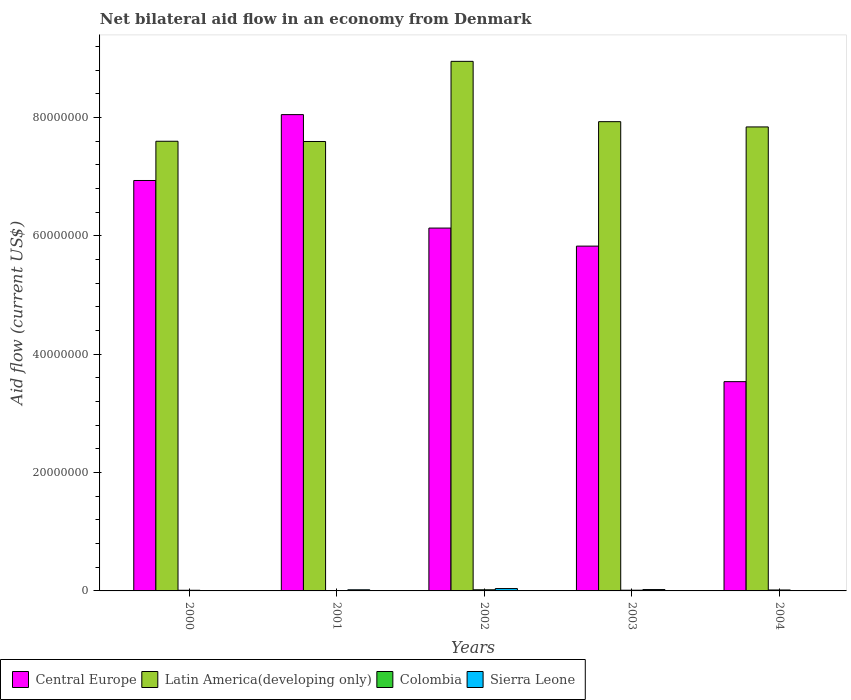How many different coloured bars are there?
Provide a succinct answer. 4. How many groups of bars are there?
Provide a succinct answer. 5. Are the number of bars on each tick of the X-axis equal?
Your answer should be compact. No. How many bars are there on the 5th tick from the left?
Provide a succinct answer. 3. What is the label of the 1st group of bars from the left?
Keep it short and to the point. 2000. In how many cases, is the number of bars for a given year not equal to the number of legend labels?
Offer a terse response. 1. What is the net bilateral aid flow in Central Europe in 2002?
Offer a terse response. 6.13e+07. Across all years, what is the maximum net bilateral aid flow in Central Europe?
Your answer should be compact. 8.05e+07. Across all years, what is the minimum net bilateral aid flow in Latin America(developing only)?
Your response must be concise. 7.59e+07. In which year was the net bilateral aid flow in Central Europe maximum?
Your answer should be very brief. 2001. What is the total net bilateral aid flow in Latin America(developing only) in the graph?
Ensure brevity in your answer.  3.99e+08. What is the difference between the net bilateral aid flow in Central Europe in 2001 and that in 2004?
Your answer should be very brief. 4.51e+07. What is the difference between the net bilateral aid flow in Central Europe in 2000 and the net bilateral aid flow in Sierra Leone in 2001?
Make the answer very short. 6.92e+07. What is the average net bilateral aid flow in Latin America(developing only) per year?
Your answer should be compact. 7.98e+07. In the year 2001, what is the difference between the net bilateral aid flow in Colombia and net bilateral aid flow in Central Europe?
Make the answer very short. -8.04e+07. What is the ratio of the net bilateral aid flow in Central Europe in 2000 to that in 2001?
Your answer should be very brief. 0.86. Is the net bilateral aid flow in Latin America(developing only) in 2000 less than that in 2004?
Offer a very short reply. Yes. What is the difference between the highest and the second highest net bilateral aid flow in Colombia?
Offer a very short reply. 3.00e+04. Is the sum of the net bilateral aid flow in Central Europe in 2000 and 2003 greater than the maximum net bilateral aid flow in Sierra Leone across all years?
Give a very brief answer. Yes. Is it the case that in every year, the sum of the net bilateral aid flow in Latin America(developing only) and net bilateral aid flow in Sierra Leone is greater than the sum of net bilateral aid flow in Central Europe and net bilateral aid flow in Colombia?
Make the answer very short. No. How many bars are there?
Offer a very short reply. 19. Are all the bars in the graph horizontal?
Keep it short and to the point. No. How many years are there in the graph?
Ensure brevity in your answer.  5. Are the values on the major ticks of Y-axis written in scientific E-notation?
Provide a succinct answer. No. Does the graph contain grids?
Provide a succinct answer. No. How are the legend labels stacked?
Offer a very short reply. Horizontal. What is the title of the graph?
Make the answer very short. Net bilateral aid flow in an economy from Denmark. What is the label or title of the X-axis?
Offer a terse response. Years. What is the label or title of the Y-axis?
Your answer should be very brief. Aid flow (current US$). What is the Aid flow (current US$) in Central Europe in 2000?
Make the answer very short. 6.94e+07. What is the Aid flow (current US$) in Latin America(developing only) in 2000?
Make the answer very short. 7.60e+07. What is the Aid flow (current US$) of Sierra Leone in 2000?
Provide a short and direct response. 3.00e+04. What is the Aid flow (current US$) of Central Europe in 2001?
Your answer should be compact. 8.05e+07. What is the Aid flow (current US$) in Latin America(developing only) in 2001?
Provide a succinct answer. 7.59e+07. What is the Aid flow (current US$) of Colombia in 2001?
Ensure brevity in your answer.  4.00e+04. What is the Aid flow (current US$) of Sierra Leone in 2001?
Offer a very short reply. 1.90e+05. What is the Aid flow (current US$) of Central Europe in 2002?
Your answer should be very brief. 6.13e+07. What is the Aid flow (current US$) of Latin America(developing only) in 2002?
Your response must be concise. 8.95e+07. What is the Aid flow (current US$) in Sierra Leone in 2002?
Offer a very short reply. 4.00e+05. What is the Aid flow (current US$) in Central Europe in 2003?
Your answer should be compact. 5.83e+07. What is the Aid flow (current US$) of Latin America(developing only) in 2003?
Offer a very short reply. 7.93e+07. What is the Aid flow (current US$) of Colombia in 2003?
Your answer should be very brief. 1.20e+05. What is the Aid flow (current US$) of Central Europe in 2004?
Your answer should be compact. 3.54e+07. What is the Aid flow (current US$) of Latin America(developing only) in 2004?
Offer a terse response. 7.84e+07. Across all years, what is the maximum Aid flow (current US$) of Central Europe?
Provide a short and direct response. 8.05e+07. Across all years, what is the maximum Aid flow (current US$) in Latin America(developing only)?
Give a very brief answer. 8.95e+07. Across all years, what is the maximum Aid flow (current US$) in Colombia?
Ensure brevity in your answer.  1.90e+05. Across all years, what is the maximum Aid flow (current US$) of Sierra Leone?
Your answer should be very brief. 4.00e+05. Across all years, what is the minimum Aid flow (current US$) in Central Europe?
Ensure brevity in your answer.  3.54e+07. Across all years, what is the minimum Aid flow (current US$) of Latin America(developing only)?
Give a very brief answer. 7.59e+07. Across all years, what is the minimum Aid flow (current US$) in Colombia?
Your answer should be compact. 4.00e+04. Across all years, what is the minimum Aid flow (current US$) of Sierra Leone?
Provide a short and direct response. 0. What is the total Aid flow (current US$) in Central Europe in the graph?
Provide a short and direct response. 3.05e+08. What is the total Aid flow (current US$) in Latin America(developing only) in the graph?
Give a very brief answer. 3.99e+08. What is the total Aid flow (current US$) of Colombia in the graph?
Provide a short and direct response. 6.20e+05. What is the total Aid flow (current US$) in Sierra Leone in the graph?
Keep it short and to the point. 8.50e+05. What is the difference between the Aid flow (current US$) in Central Europe in 2000 and that in 2001?
Offer a very short reply. -1.11e+07. What is the difference between the Aid flow (current US$) in Latin America(developing only) in 2000 and that in 2001?
Make the answer very short. 4.00e+04. What is the difference between the Aid flow (current US$) in Colombia in 2000 and that in 2001?
Your answer should be very brief. 7.00e+04. What is the difference between the Aid flow (current US$) of Sierra Leone in 2000 and that in 2001?
Give a very brief answer. -1.60e+05. What is the difference between the Aid flow (current US$) in Central Europe in 2000 and that in 2002?
Your answer should be compact. 8.04e+06. What is the difference between the Aid flow (current US$) in Latin America(developing only) in 2000 and that in 2002?
Your answer should be compact. -1.35e+07. What is the difference between the Aid flow (current US$) of Colombia in 2000 and that in 2002?
Give a very brief answer. -8.00e+04. What is the difference between the Aid flow (current US$) of Sierra Leone in 2000 and that in 2002?
Ensure brevity in your answer.  -3.70e+05. What is the difference between the Aid flow (current US$) in Central Europe in 2000 and that in 2003?
Make the answer very short. 1.11e+07. What is the difference between the Aid flow (current US$) in Latin America(developing only) in 2000 and that in 2003?
Offer a terse response. -3.31e+06. What is the difference between the Aid flow (current US$) of Colombia in 2000 and that in 2003?
Give a very brief answer. -10000. What is the difference between the Aid flow (current US$) in Sierra Leone in 2000 and that in 2003?
Give a very brief answer. -2.00e+05. What is the difference between the Aid flow (current US$) in Central Europe in 2000 and that in 2004?
Your answer should be very brief. 3.40e+07. What is the difference between the Aid flow (current US$) of Latin America(developing only) in 2000 and that in 2004?
Your response must be concise. -2.42e+06. What is the difference between the Aid flow (current US$) of Central Europe in 2001 and that in 2002?
Offer a very short reply. 1.92e+07. What is the difference between the Aid flow (current US$) in Latin America(developing only) in 2001 and that in 2002?
Your response must be concise. -1.35e+07. What is the difference between the Aid flow (current US$) in Colombia in 2001 and that in 2002?
Make the answer very short. -1.50e+05. What is the difference between the Aid flow (current US$) in Sierra Leone in 2001 and that in 2002?
Provide a succinct answer. -2.10e+05. What is the difference between the Aid flow (current US$) of Central Europe in 2001 and that in 2003?
Provide a short and direct response. 2.22e+07. What is the difference between the Aid flow (current US$) in Latin America(developing only) in 2001 and that in 2003?
Your answer should be compact. -3.35e+06. What is the difference between the Aid flow (current US$) in Sierra Leone in 2001 and that in 2003?
Give a very brief answer. -4.00e+04. What is the difference between the Aid flow (current US$) of Central Europe in 2001 and that in 2004?
Your answer should be very brief. 4.51e+07. What is the difference between the Aid flow (current US$) in Latin America(developing only) in 2001 and that in 2004?
Offer a terse response. -2.46e+06. What is the difference between the Aid flow (current US$) in Colombia in 2001 and that in 2004?
Give a very brief answer. -1.20e+05. What is the difference between the Aid flow (current US$) in Central Europe in 2002 and that in 2003?
Keep it short and to the point. 3.05e+06. What is the difference between the Aid flow (current US$) in Latin America(developing only) in 2002 and that in 2003?
Your answer should be very brief. 1.02e+07. What is the difference between the Aid flow (current US$) of Colombia in 2002 and that in 2003?
Your response must be concise. 7.00e+04. What is the difference between the Aid flow (current US$) in Sierra Leone in 2002 and that in 2003?
Ensure brevity in your answer.  1.70e+05. What is the difference between the Aid flow (current US$) in Central Europe in 2002 and that in 2004?
Make the answer very short. 2.60e+07. What is the difference between the Aid flow (current US$) of Latin America(developing only) in 2002 and that in 2004?
Make the answer very short. 1.11e+07. What is the difference between the Aid flow (current US$) of Colombia in 2002 and that in 2004?
Ensure brevity in your answer.  3.00e+04. What is the difference between the Aid flow (current US$) of Central Europe in 2003 and that in 2004?
Offer a very short reply. 2.29e+07. What is the difference between the Aid flow (current US$) in Latin America(developing only) in 2003 and that in 2004?
Keep it short and to the point. 8.90e+05. What is the difference between the Aid flow (current US$) of Central Europe in 2000 and the Aid flow (current US$) of Latin America(developing only) in 2001?
Offer a terse response. -6.59e+06. What is the difference between the Aid flow (current US$) of Central Europe in 2000 and the Aid flow (current US$) of Colombia in 2001?
Make the answer very short. 6.93e+07. What is the difference between the Aid flow (current US$) in Central Europe in 2000 and the Aid flow (current US$) in Sierra Leone in 2001?
Offer a terse response. 6.92e+07. What is the difference between the Aid flow (current US$) in Latin America(developing only) in 2000 and the Aid flow (current US$) in Colombia in 2001?
Ensure brevity in your answer.  7.59e+07. What is the difference between the Aid flow (current US$) in Latin America(developing only) in 2000 and the Aid flow (current US$) in Sierra Leone in 2001?
Offer a terse response. 7.58e+07. What is the difference between the Aid flow (current US$) of Colombia in 2000 and the Aid flow (current US$) of Sierra Leone in 2001?
Provide a succinct answer. -8.00e+04. What is the difference between the Aid flow (current US$) in Central Europe in 2000 and the Aid flow (current US$) in Latin America(developing only) in 2002?
Your answer should be very brief. -2.01e+07. What is the difference between the Aid flow (current US$) of Central Europe in 2000 and the Aid flow (current US$) of Colombia in 2002?
Your response must be concise. 6.92e+07. What is the difference between the Aid flow (current US$) of Central Europe in 2000 and the Aid flow (current US$) of Sierra Leone in 2002?
Offer a terse response. 6.90e+07. What is the difference between the Aid flow (current US$) in Latin America(developing only) in 2000 and the Aid flow (current US$) in Colombia in 2002?
Your response must be concise. 7.58e+07. What is the difference between the Aid flow (current US$) in Latin America(developing only) in 2000 and the Aid flow (current US$) in Sierra Leone in 2002?
Give a very brief answer. 7.56e+07. What is the difference between the Aid flow (current US$) in Colombia in 2000 and the Aid flow (current US$) in Sierra Leone in 2002?
Keep it short and to the point. -2.90e+05. What is the difference between the Aid flow (current US$) in Central Europe in 2000 and the Aid flow (current US$) in Latin America(developing only) in 2003?
Provide a succinct answer. -9.94e+06. What is the difference between the Aid flow (current US$) in Central Europe in 2000 and the Aid flow (current US$) in Colombia in 2003?
Provide a succinct answer. 6.92e+07. What is the difference between the Aid flow (current US$) of Central Europe in 2000 and the Aid flow (current US$) of Sierra Leone in 2003?
Your answer should be very brief. 6.91e+07. What is the difference between the Aid flow (current US$) of Latin America(developing only) in 2000 and the Aid flow (current US$) of Colombia in 2003?
Offer a terse response. 7.59e+07. What is the difference between the Aid flow (current US$) of Latin America(developing only) in 2000 and the Aid flow (current US$) of Sierra Leone in 2003?
Make the answer very short. 7.58e+07. What is the difference between the Aid flow (current US$) in Colombia in 2000 and the Aid flow (current US$) in Sierra Leone in 2003?
Ensure brevity in your answer.  -1.20e+05. What is the difference between the Aid flow (current US$) in Central Europe in 2000 and the Aid flow (current US$) in Latin America(developing only) in 2004?
Your response must be concise. -9.05e+06. What is the difference between the Aid flow (current US$) in Central Europe in 2000 and the Aid flow (current US$) in Colombia in 2004?
Provide a succinct answer. 6.92e+07. What is the difference between the Aid flow (current US$) in Latin America(developing only) in 2000 and the Aid flow (current US$) in Colombia in 2004?
Give a very brief answer. 7.58e+07. What is the difference between the Aid flow (current US$) in Central Europe in 2001 and the Aid flow (current US$) in Latin America(developing only) in 2002?
Provide a short and direct response. -9.00e+06. What is the difference between the Aid flow (current US$) of Central Europe in 2001 and the Aid flow (current US$) of Colombia in 2002?
Give a very brief answer. 8.03e+07. What is the difference between the Aid flow (current US$) of Central Europe in 2001 and the Aid flow (current US$) of Sierra Leone in 2002?
Your answer should be very brief. 8.01e+07. What is the difference between the Aid flow (current US$) in Latin America(developing only) in 2001 and the Aid flow (current US$) in Colombia in 2002?
Give a very brief answer. 7.58e+07. What is the difference between the Aid flow (current US$) in Latin America(developing only) in 2001 and the Aid flow (current US$) in Sierra Leone in 2002?
Provide a short and direct response. 7.55e+07. What is the difference between the Aid flow (current US$) in Colombia in 2001 and the Aid flow (current US$) in Sierra Leone in 2002?
Your response must be concise. -3.60e+05. What is the difference between the Aid flow (current US$) of Central Europe in 2001 and the Aid flow (current US$) of Latin America(developing only) in 2003?
Keep it short and to the point. 1.19e+06. What is the difference between the Aid flow (current US$) of Central Europe in 2001 and the Aid flow (current US$) of Colombia in 2003?
Your answer should be very brief. 8.04e+07. What is the difference between the Aid flow (current US$) of Central Europe in 2001 and the Aid flow (current US$) of Sierra Leone in 2003?
Provide a succinct answer. 8.02e+07. What is the difference between the Aid flow (current US$) in Latin America(developing only) in 2001 and the Aid flow (current US$) in Colombia in 2003?
Provide a short and direct response. 7.58e+07. What is the difference between the Aid flow (current US$) in Latin America(developing only) in 2001 and the Aid flow (current US$) in Sierra Leone in 2003?
Offer a very short reply. 7.57e+07. What is the difference between the Aid flow (current US$) of Colombia in 2001 and the Aid flow (current US$) of Sierra Leone in 2003?
Give a very brief answer. -1.90e+05. What is the difference between the Aid flow (current US$) of Central Europe in 2001 and the Aid flow (current US$) of Latin America(developing only) in 2004?
Your answer should be compact. 2.08e+06. What is the difference between the Aid flow (current US$) of Central Europe in 2001 and the Aid flow (current US$) of Colombia in 2004?
Keep it short and to the point. 8.03e+07. What is the difference between the Aid flow (current US$) of Latin America(developing only) in 2001 and the Aid flow (current US$) of Colombia in 2004?
Make the answer very short. 7.58e+07. What is the difference between the Aid flow (current US$) in Central Europe in 2002 and the Aid flow (current US$) in Latin America(developing only) in 2003?
Your response must be concise. -1.80e+07. What is the difference between the Aid flow (current US$) in Central Europe in 2002 and the Aid flow (current US$) in Colombia in 2003?
Make the answer very short. 6.12e+07. What is the difference between the Aid flow (current US$) in Central Europe in 2002 and the Aid flow (current US$) in Sierra Leone in 2003?
Your answer should be compact. 6.11e+07. What is the difference between the Aid flow (current US$) of Latin America(developing only) in 2002 and the Aid flow (current US$) of Colombia in 2003?
Offer a terse response. 8.94e+07. What is the difference between the Aid flow (current US$) of Latin America(developing only) in 2002 and the Aid flow (current US$) of Sierra Leone in 2003?
Your answer should be compact. 8.92e+07. What is the difference between the Aid flow (current US$) of Colombia in 2002 and the Aid flow (current US$) of Sierra Leone in 2003?
Offer a very short reply. -4.00e+04. What is the difference between the Aid flow (current US$) of Central Europe in 2002 and the Aid flow (current US$) of Latin America(developing only) in 2004?
Ensure brevity in your answer.  -1.71e+07. What is the difference between the Aid flow (current US$) of Central Europe in 2002 and the Aid flow (current US$) of Colombia in 2004?
Provide a short and direct response. 6.12e+07. What is the difference between the Aid flow (current US$) in Latin America(developing only) in 2002 and the Aid flow (current US$) in Colombia in 2004?
Give a very brief answer. 8.93e+07. What is the difference between the Aid flow (current US$) of Central Europe in 2003 and the Aid flow (current US$) of Latin America(developing only) in 2004?
Provide a short and direct response. -2.01e+07. What is the difference between the Aid flow (current US$) of Central Europe in 2003 and the Aid flow (current US$) of Colombia in 2004?
Provide a short and direct response. 5.81e+07. What is the difference between the Aid flow (current US$) in Latin America(developing only) in 2003 and the Aid flow (current US$) in Colombia in 2004?
Give a very brief answer. 7.91e+07. What is the average Aid flow (current US$) of Central Europe per year?
Give a very brief answer. 6.10e+07. What is the average Aid flow (current US$) of Latin America(developing only) per year?
Your response must be concise. 7.98e+07. What is the average Aid flow (current US$) of Colombia per year?
Provide a succinct answer. 1.24e+05. In the year 2000, what is the difference between the Aid flow (current US$) of Central Europe and Aid flow (current US$) of Latin America(developing only)?
Offer a very short reply. -6.63e+06. In the year 2000, what is the difference between the Aid flow (current US$) in Central Europe and Aid flow (current US$) in Colombia?
Provide a short and direct response. 6.92e+07. In the year 2000, what is the difference between the Aid flow (current US$) of Central Europe and Aid flow (current US$) of Sierra Leone?
Your answer should be very brief. 6.93e+07. In the year 2000, what is the difference between the Aid flow (current US$) of Latin America(developing only) and Aid flow (current US$) of Colombia?
Ensure brevity in your answer.  7.59e+07. In the year 2000, what is the difference between the Aid flow (current US$) in Latin America(developing only) and Aid flow (current US$) in Sierra Leone?
Provide a succinct answer. 7.60e+07. In the year 2000, what is the difference between the Aid flow (current US$) in Colombia and Aid flow (current US$) in Sierra Leone?
Provide a succinct answer. 8.00e+04. In the year 2001, what is the difference between the Aid flow (current US$) of Central Europe and Aid flow (current US$) of Latin America(developing only)?
Offer a very short reply. 4.54e+06. In the year 2001, what is the difference between the Aid flow (current US$) in Central Europe and Aid flow (current US$) in Colombia?
Keep it short and to the point. 8.04e+07. In the year 2001, what is the difference between the Aid flow (current US$) in Central Europe and Aid flow (current US$) in Sierra Leone?
Ensure brevity in your answer.  8.03e+07. In the year 2001, what is the difference between the Aid flow (current US$) of Latin America(developing only) and Aid flow (current US$) of Colombia?
Provide a short and direct response. 7.59e+07. In the year 2001, what is the difference between the Aid flow (current US$) in Latin America(developing only) and Aid flow (current US$) in Sierra Leone?
Give a very brief answer. 7.58e+07. In the year 2002, what is the difference between the Aid flow (current US$) in Central Europe and Aid flow (current US$) in Latin America(developing only)?
Provide a succinct answer. -2.82e+07. In the year 2002, what is the difference between the Aid flow (current US$) in Central Europe and Aid flow (current US$) in Colombia?
Your answer should be very brief. 6.11e+07. In the year 2002, what is the difference between the Aid flow (current US$) in Central Europe and Aid flow (current US$) in Sierra Leone?
Keep it short and to the point. 6.09e+07. In the year 2002, what is the difference between the Aid flow (current US$) in Latin America(developing only) and Aid flow (current US$) in Colombia?
Make the answer very short. 8.93e+07. In the year 2002, what is the difference between the Aid flow (current US$) in Latin America(developing only) and Aid flow (current US$) in Sierra Leone?
Your answer should be compact. 8.91e+07. In the year 2002, what is the difference between the Aid flow (current US$) of Colombia and Aid flow (current US$) of Sierra Leone?
Offer a terse response. -2.10e+05. In the year 2003, what is the difference between the Aid flow (current US$) of Central Europe and Aid flow (current US$) of Latin America(developing only)?
Offer a very short reply. -2.10e+07. In the year 2003, what is the difference between the Aid flow (current US$) in Central Europe and Aid flow (current US$) in Colombia?
Give a very brief answer. 5.81e+07. In the year 2003, what is the difference between the Aid flow (current US$) in Central Europe and Aid flow (current US$) in Sierra Leone?
Offer a very short reply. 5.80e+07. In the year 2003, what is the difference between the Aid flow (current US$) of Latin America(developing only) and Aid flow (current US$) of Colombia?
Provide a short and direct response. 7.92e+07. In the year 2003, what is the difference between the Aid flow (current US$) in Latin America(developing only) and Aid flow (current US$) in Sierra Leone?
Keep it short and to the point. 7.91e+07. In the year 2003, what is the difference between the Aid flow (current US$) of Colombia and Aid flow (current US$) of Sierra Leone?
Offer a terse response. -1.10e+05. In the year 2004, what is the difference between the Aid flow (current US$) of Central Europe and Aid flow (current US$) of Latin America(developing only)?
Offer a very short reply. -4.30e+07. In the year 2004, what is the difference between the Aid flow (current US$) of Central Europe and Aid flow (current US$) of Colombia?
Offer a very short reply. 3.52e+07. In the year 2004, what is the difference between the Aid flow (current US$) in Latin America(developing only) and Aid flow (current US$) in Colombia?
Ensure brevity in your answer.  7.82e+07. What is the ratio of the Aid flow (current US$) of Central Europe in 2000 to that in 2001?
Make the answer very short. 0.86. What is the ratio of the Aid flow (current US$) of Colombia in 2000 to that in 2001?
Provide a short and direct response. 2.75. What is the ratio of the Aid flow (current US$) in Sierra Leone in 2000 to that in 2001?
Offer a very short reply. 0.16. What is the ratio of the Aid flow (current US$) in Central Europe in 2000 to that in 2002?
Give a very brief answer. 1.13. What is the ratio of the Aid flow (current US$) of Latin America(developing only) in 2000 to that in 2002?
Provide a succinct answer. 0.85. What is the ratio of the Aid flow (current US$) of Colombia in 2000 to that in 2002?
Keep it short and to the point. 0.58. What is the ratio of the Aid flow (current US$) of Sierra Leone in 2000 to that in 2002?
Ensure brevity in your answer.  0.07. What is the ratio of the Aid flow (current US$) of Central Europe in 2000 to that in 2003?
Provide a succinct answer. 1.19. What is the ratio of the Aid flow (current US$) of Colombia in 2000 to that in 2003?
Your answer should be compact. 0.92. What is the ratio of the Aid flow (current US$) in Sierra Leone in 2000 to that in 2003?
Your answer should be very brief. 0.13. What is the ratio of the Aid flow (current US$) in Central Europe in 2000 to that in 2004?
Offer a terse response. 1.96. What is the ratio of the Aid flow (current US$) in Latin America(developing only) in 2000 to that in 2004?
Give a very brief answer. 0.97. What is the ratio of the Aid flow (current US$) of Colombia in 2000 to that in 2004?
Give a very brief answer. 0.69. What is the ratio of the Aid flow (current US$) of Central Europe in 2001 to that in 2002?
Your response must be concise. 1.31. What is the ratio of the Aid flow (current US$) of Latin America(developing only) in 2001 to that in 2002?
Keep it short and to the point. 0.85. What is the ratio of the Aid flow (current US$) in Colombia in 2001 to that in 2002?
Offer a terse response. 0.21. What is the ratio of the Aid flow (current US$) in Sierra Leone in 2001 to that in 2002?
Offer a terse response. 0.47. What is the ratio of the Aid flow (current US$) of Central Europe in 2001 to that in 2003?
Provide a short and direct response. 1.38. What is the ratio of the Aid flow (current US$) of Latin America(developing only) in 2001 to that in 2003?
Offer a very short reply. 0.96. What is the ratio of the Aid flow (current US$) in Colombia in 2001 to that in 2003?
Give a very brief answer. 0.33. What is the ratio of the Aid flow (current US$) of Sierra Leone in 2001 to that in 2003?
Provide a short and direct response. 0.83. What is the ratio of the Aid flow (current US$) in Central Europe in 2001 to that in 2004?
Provide a short and direct response. 2.28. What is the ratio of the Aid flow (current US$) of Latin America(developing only) in 2001 to that in 2004?
Offer a very short reply. 0.97. What is the ratio of the Aid flow (current US$) of Central Europe in 2002 to that in 2003?
Keep it short and to the point. 1.05. What is the ratio of the Aid flow (current US$) of Latin America(developing only) in 2002 to that in 2003?
Make the answer very short. 1.13. What is the ratio of the Aid flow (current US$) in Colombia in 2002 to that in 2003?
Provide a succinct answer. 1.58. What is the ratio of the Aid flow (current US$) of Sierra Leone in 2002 to that in 2003?
Provide a short and direct response. 1.74. What is the ratio of the Aid flow (current US$) in Central Europe in 2002 to that in 2004?
Keep it short and to the point. 1.73. What is the ratio of the Aid flow (current US$) in Latin America(developing only) in 2002 to that in 2004?
Offer a terse response. 1.14. What is the ratio of the Aid flow (current US$) in Colombia in 2002 to that in 2004?
Your answer should be very brief. 1.19. What is the ratio of the Aid flow (current US$) in Central Europe in 2003 to that in 2004?
Provide a succinct answer. 1.65. What is the ratio of the Aid flow (current US$) in Latin America(developing only) in 2003 to that in 2004?
Offer a terse response. 1.01. What is the difference between the highest and the second highest Aid flow (current US$) in Central Europe?
Provide a short and direct response. 1.11e+07. What is the difference between the highest and the second highest Aid flow (current US$) in Latin America(developing only)?
Keep it short and to the point. 1.02e+07. What is the difference between the highest and the lowest Aid flow (current US$) of Central Europe?
Your answer should be compact. 4.51e+07. What is the difference between the highest and the lowest Aid flow (current US$) of Latin America(developing only)?
Offer a terse response. 1.35e+07. What is the difference between the highest and the lowest Aid flow (current US$) of Colombia?
Give a very brief answer. 1.50e+05. What is the difference between the highest and the lowest Aid flow (current US$) in Sierra Leone?
Your answer should be very brief. 4.00e+05. 